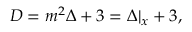<formula> <loc_0><loc_0><loc_500><loc_500>D = m ^ { 2 } \Delta + 3 = \Delta | _ { x } + 3 ,</formula> 